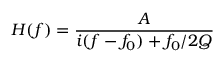<formula> <loc_0><loc_0><loc_500><loc_500>H ( f ) = \frac { A } { i ( f - f _ { 0 } ) + f _ { 0 } / 2 Q }</formula> 